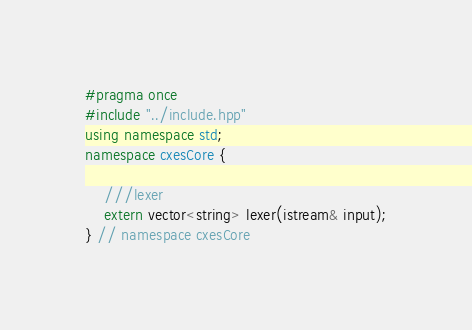Convert code to text. <code><loc_0><loc_0><loc_500><loc_500><_C++_>#pragma once
#include "../include.hpp"
using namespace std;
namespace cxesCore {

	///lexer
	extern vector<string> lexer(istream& input);
} // namespace cxesCore
</code> 